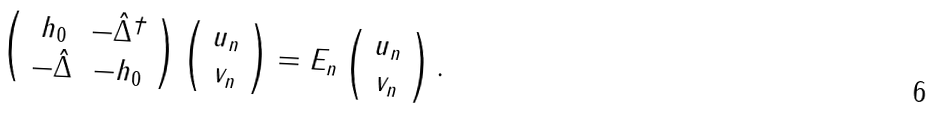Convert formula to latex. <formula><loc_0><loc_0><loc_500><loc_500>\left ( \begin{array} { c c } h _ { 0 } & - \hat { \Delta } ^ { \dagger } \\ - \hat { \Delta } & - h _ { 0 } \end{array} \right ) \left ( \begin{array} { c } u _ { n } \\ v _ { n } \end{array} \right ) = E _ { n } \left ( \begin{array} { c } u _ { n } \\ v _ { n } \end{array} \right ) .</formula> 